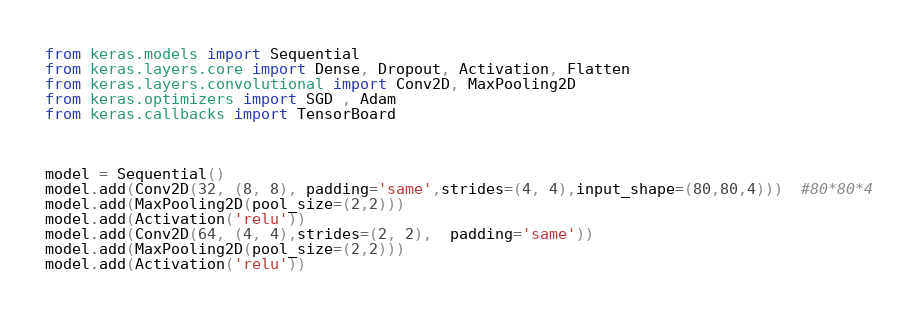<code> <loc_0><loc_0><loc_500><loc_500><_Python_>from keras.models import Sequential
from keras.layers.core import Dense, Dropout, Activation, Flatten
from keras.layers.convolutional import Conv2D, MaxPooling2D
from keras.optimizers import SGD , Adam
from keras.callbacks import TensorBoard



model = Sequential()
model.add(Conv2D(32, (8, 8), padding='same',strides=(4, 4),input_shape=(80,80,4)))  #80*80*4
model.add(MaxPooling2D(pool_size=(2,2)))
model.add(Activation('relu'))
model.add(Conv2D(64, (4, 4),strides=(2, 2),  padding='same'))
model.add(MaxPooling2D(pool_size=(2,2)))
model.add(Activation('relu'))</code> 